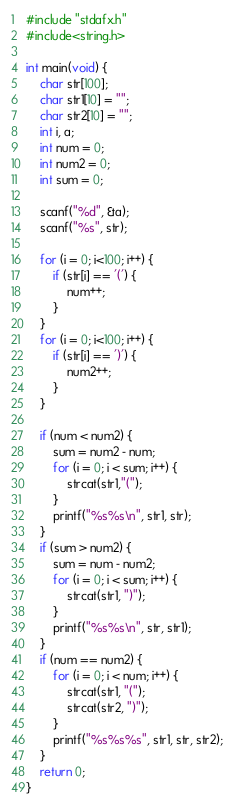<code> <loc_0><loc_0><loc_500><loc_500><_C++_>#include "stdafx.h"
#include<string.h>

int main(void) {
	char str[100];
	char str1[10] = "";
	char str2[10] = "";
	int i, a;
	int num = 0;
	int num2 = 0;
	int sum = 0;

	scanf("%d", &a);
	scanf("%s", str);

	for (i = 0; i<100; i++) {
		if (str[i] == '(') {
			num++;
		}
	}
	for (i = 0; i<100; i++) {
		if (str[i] == ')') {
			num2++;
		}
	}

	if (num < num2) {
		sum = num2 - num;
		for (i = 0; i < sum; i++) {
			strcat(str1,"(");
		}
		printf("%s%s\n", str1, str);
	}
	if (sum > num2) {
		sum = num - num2;
		for (i = 0; i < sum; i++) {
			strcat(str1, ")");
		}
		printf("%s%s\n", str, str1);
	}
	if (num == num2) {
		for (i = 0; i < num; i++) {
			strcat(str1, "(");
			strcat(str2, ")");
		}
		printf("%s%s%s", str1, str, str2);
	}
	return 0;
}</code> 